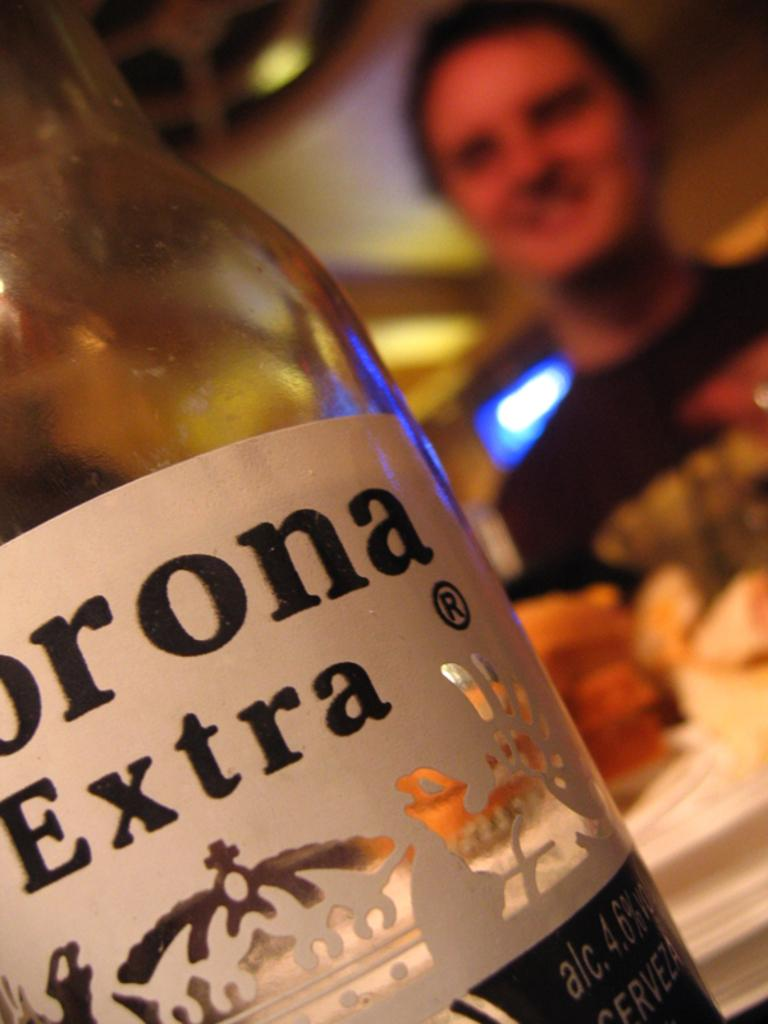What object can be seen in the image? There is a bottle in the image. What is on the bottle? The bottle has a sticker on it. What can be read on the sticker? There are words on the sticker. Can you describe the setting of the image? There is a man in the background of the image. What type of rice can be seen in the image? There is no rice present in the image. What thrilling activity is the man in the background participating in? The image does not show the man participating in any activity, so it cannot be determined if it is thrilling or not. 